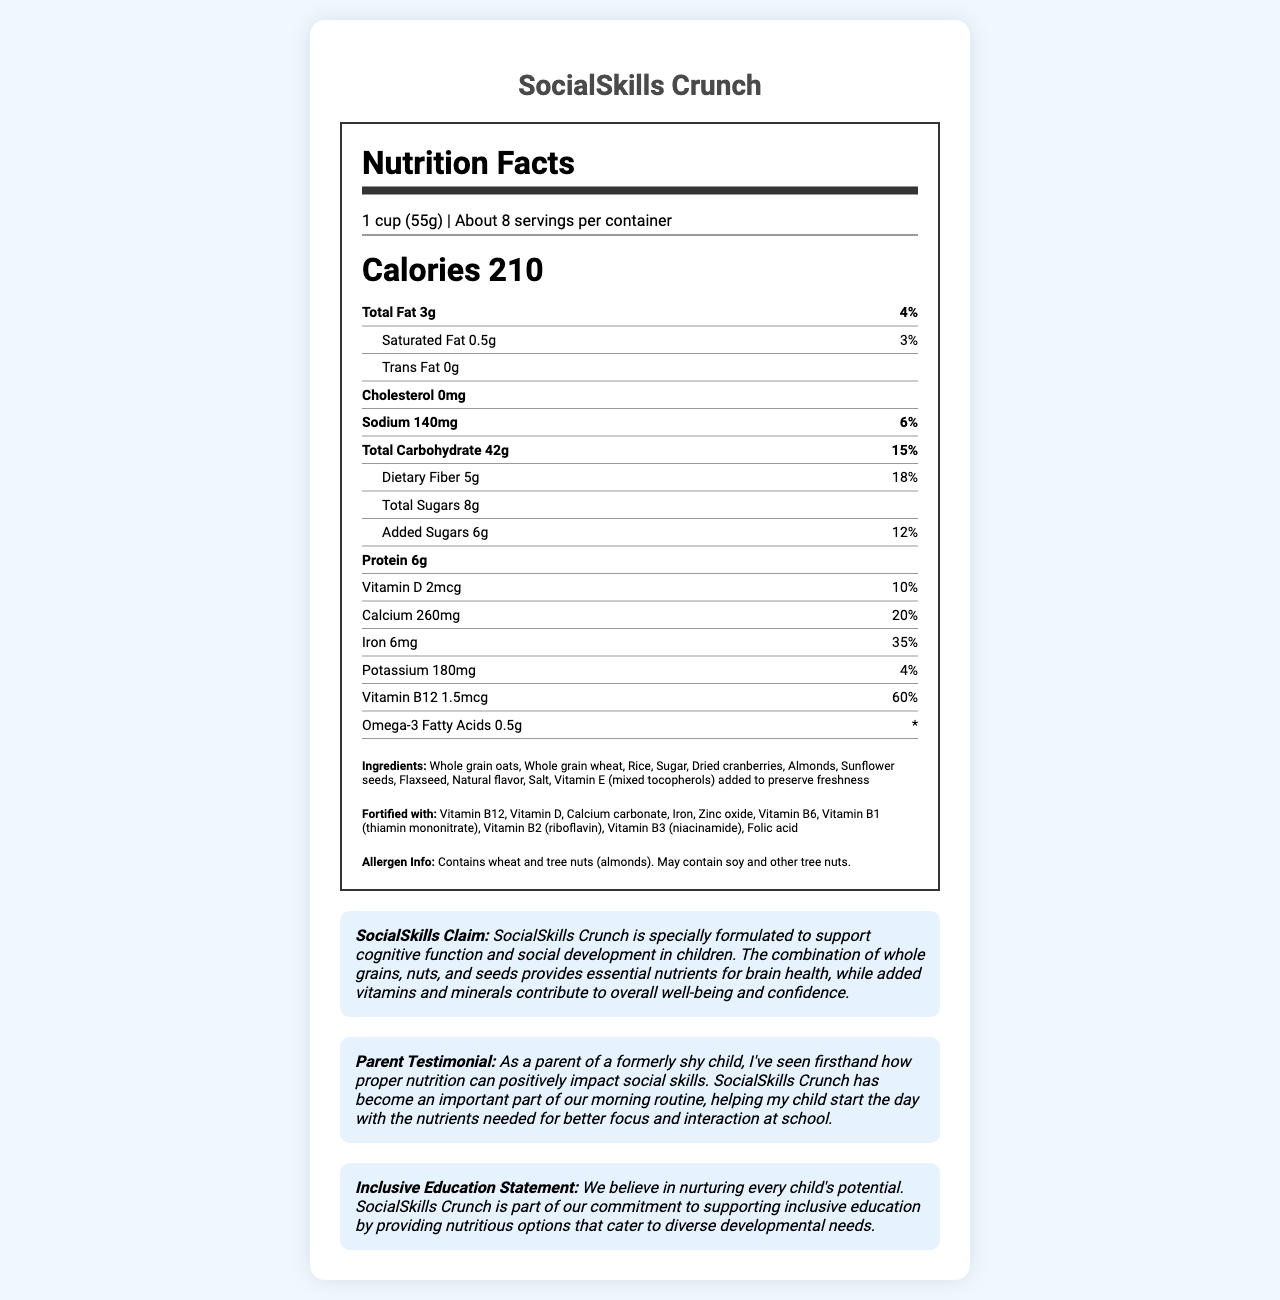what is the serving size for SocialSkills Crunch? The serving size is clearly stated at the top of the Nutrition Facts section as "1 cup (55g)".
Answer: 1 cup (55g) how many servings are in a container? The document specifies that there are about 8 servings per container in the serving info section.
Answer: About 8 how many grams of protein does one serving of SocialSkills Crunch contain? The protein content is listed in the nutrition facts under "Protein" as 6g per serving.
Answer: 6g what percentage of the daily value of iron does one serving provide? The iron content is listed with a percent daily value of 35%.
Answer: 35% what is the amount of added sugars in one serving? The amount of added sugars is provided in the nutrition facts as 6g.
Answer: 6g which ingredient preserves freshness in SocialSkills Crunch? The list of ingredients includes "Vitamin E (mixed tocopherols) added to preserve freshness."
Answer: Vitamin E (mixed tocopherols) does SocialSkills Crunch contain omega-3 fatty acids? The nutrition facts specify that one serving contains 0.5g of omega-3 fatty acids.
Answer: Yes which of the following vitamins is NOT listed in the fortification section? A. Vitamin C B. Vitamin D C. Vitamin B1 D. Zinc oxide The fortification list includes Vitamin D, Vitamin B1, and Zinc oxide but does not mention Vitamin C.
Answer: A. Vitamin C how many grams of total carbohydrates are in one serving? The total carbohydrate content is listed in the nutrition facts as 42g per serving.
Answer: 42g what makes SocialSkills Crunch a good choice for supporting social skills in children? The document mentions the claim that the product supports social skills through a combination of whole grains, nuts, seeds, and added vitamins and minerals.
Answer: The combination of whole grains, nuts, and seeds provides essential nutrients for brain health, while added vitamins and minerals contribute to overall well-being and confidence. how much calcium is in one serving of SocialSkills Crunch? The document lists the calcium content in one serving as 260mg with a percent daily value of 20%.
Answer: 260mg which allergens are present in SocialSkills Crunch? A. Wheat B. Tree nuts (almonds) C. Soy D. All of the above The allergen information specifies that the product contains wheat and tree nuts (almonds) and may contain soy and other tree nuts.
Answer: D. All of the above how much dietary fiber does one serving of SocialSkills Crunch provide? The dietary fiber content is listed in the nutrition facts as 5g per serving.
Answer: 5g is SocialSkills Crunch cholesterol-free? The document clearly states that the cholesterol content is 0mg.
Answer: Yes what is the sodium content in one serving of SocialSkills Crunch? The sodium content is listed in the nutrition facts as 140mg with a percent daily value of 6%.
Answer: 140mg what is the total fat content in one serving of SocialSkills Crunch? The nutrition facts list the total fat content as 3g per serving.
Answer: 3g does the product help to support inclusive education? The inclusive education statement at the end of the document affirms the product's commitment to supporting inclusive education by providing nutritious options.
Answer: Yes summarize the main idea of the document. The document outlines the nutritional benefits and purpose of the SocialSkills Crunch cereal, emphasizing its role in supporting brain function and social skills in children. It also highlights the product's nutritional content, ingredients, allergen information, and social commitment.
Answer: SocialSkills Crunch is a breakfast cereal designed to support cognitive function and social development in children through a blend of whole grains, nuts, seeds, and added vitamins and minerals. The product contains various nutrients that contribute to overall brain health and confidence, along with essential daily vitamins and minerals. The packaging includes detailed nutrition facts, ingredients, allergen information, and a commitment to inclusive education. what is the sugar content in dried cranberries used in SocialSkills Crunch? The document lists dried cranberries as an ingredient, but it does not specify the sugar content in the dried cranberries specifically.
Answer: Not enough information 